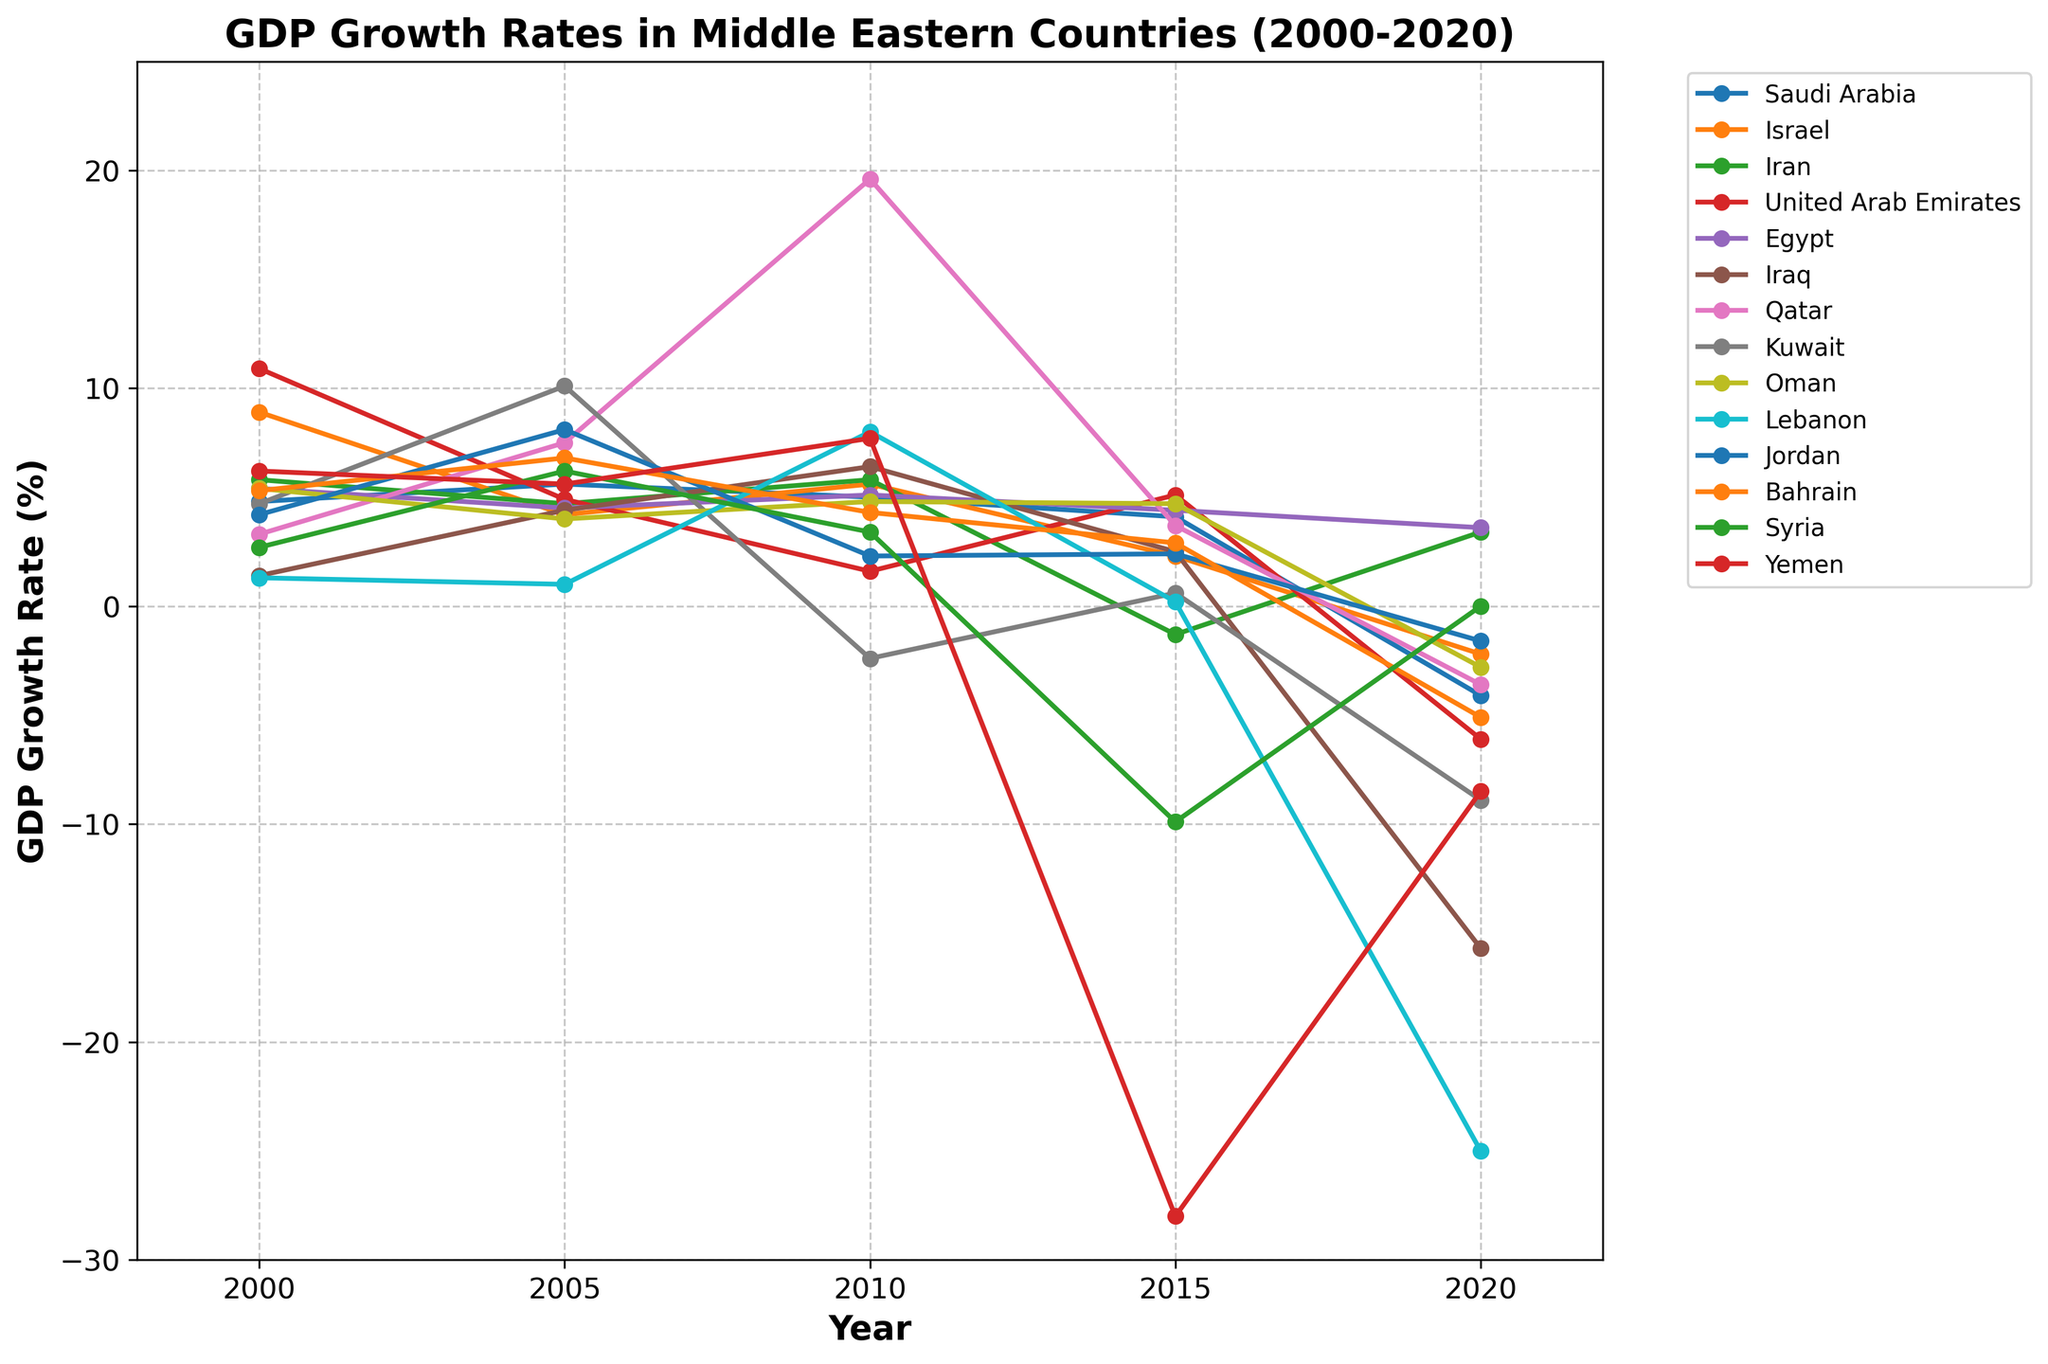what's the range of GDP growth rates for Lebanon? To find the range of GDP growth rates for Lebanon, you need to subtract the smallest value from the largest value observed for Lebanon in the chart. The largest value is 8.0 (2010) and the smallest value is -25.0 (2020). The range is 8.0 - (-25.0) = 33.0.
Answer: 33.0 which country experienced the lowest GDP growth rate in 2020? By looking at the downward slopes of the lines in 2020, the country with the steepest drop is Lebanon, which reached -25.0 in 2020.
Answer: Lebanon which country had the highest average GDP growth rate over the 20-year period? To determine the country with the highest average GDP growth rate, you have to calculate the average for each country and compare. Saudi Arabia: (4.8+5.6+5.0+4.1-4.1)/5 = 3.08, Israel: (8.9+4.2+5.6+2.3-2.2)/5 = 3.76, Iran: (5.8+4.7+5.8-1.3+3.4)/5 = 3.68, UAE: (10.9+4.9+1.6+5.1-6.1)/5 = 3.28, Egypt: (5.4+4.5+5.1+4.4+3.6)/5 = 4.6, Iraq: (1.4+4.4+6.4+2.5-15.7)/5 = -0.2, Qatar: (3.3+7.5+19.6+3.7-3.6)/5 = 6.1, Kuwait: (4.7+10.1-2.4+0.6-8.9)/5 = 0.82, Oman: (5.4+4.0+4.8+4.7-2.8)/5 = 3.22, Lebanon: (1.3+1.0+8.0+0.2-25.0)/5 = -2.9, Jordan: (4.2+8.1+2.3+2.4-1.6)/5 = 3.08, Bahrain: (5.3+6.8+4.3+2.9-5.1)/5 = 2.84, Syria: (2.7+6.2+3.4-9.9+0.0)/5 = 0.48, Yemen: (6.2+5.6+7.7-28.0-8.5)/5 = -3.4. The highest average GDP growth rate belongs to Qatar with an average of 6.1.
Answer: Qatar which countries have negative GDP growth rates in 2020? By examining the endpoints of the lines in 2020 where they dip below zero, the countries with negative GDP growth rates in 2020 are Saudi Arabia, Israel, UAE, Iraq, Qatar, Kuwait, Oman, Lebanon, Jordan, Bahrain, Syria, and Yemen.
Answer: Saudi Arabia, Israel, UAE, Iraq, Qatar, Kuwait, Oman, Lebanon, Jordan, Bahrain, Syria, Yemen what is the trend in GDP growth for Syria from 2000 to 2020? To determine the trend, look at Syria's GDP growth rate line over the timeline. It starts at 2.7% in 2000, rises to 6.2% in 2005, then drops to 3.4% in 2010, dramatically falls to -9.9% in 2015, and ends at 0.0% in 2020. The overall trend is a significant decline.
Answer: Significant decline 